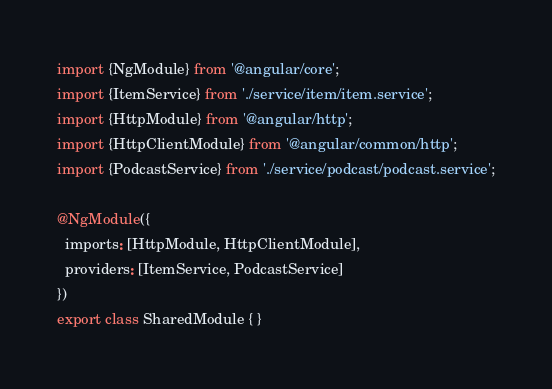<code> <loc_0><loc_0><loc_500><loc_500><_TypeScript_>import {NgModule} from '@angular/core';
import {ItemService} from './service/item/item.service';
import {HttpModule} from '@angular/http';
import {HttpClientModule} from '@angular/common/http';
import {PodcastService} from './service/podcast/podcast.service';

@NgModule({
  imports: [HttpModule, HttpClientModule],
  providers: [ItemService, PodcastService]
})
export class SharedModule { }
</code> 